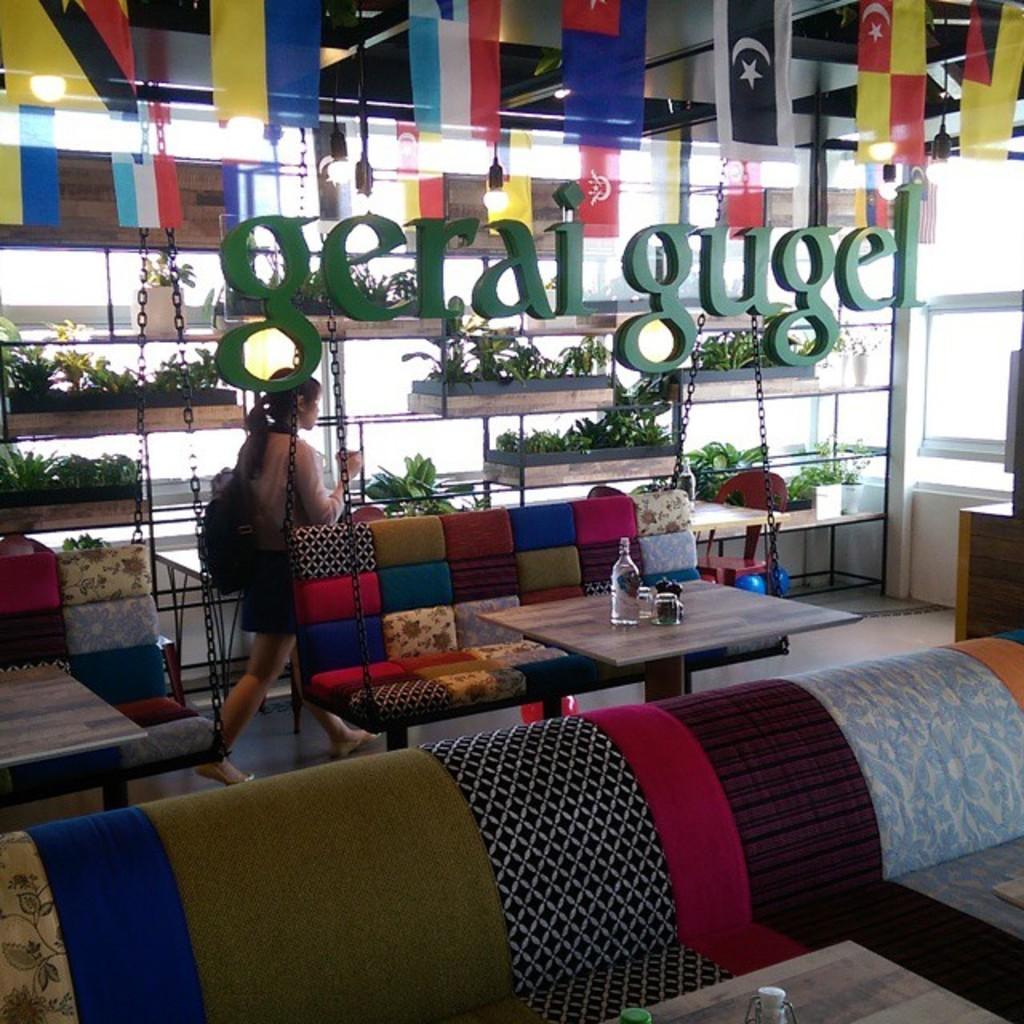Can you describe this image briefly? There is a colorful cradle. In front of that there is a table. On that table there are bottles and glasses. And we can see colorful sofa. And we can see a name hanging. And at the back side there are some plants. And there is a lady walking. She is wearing a bag. 